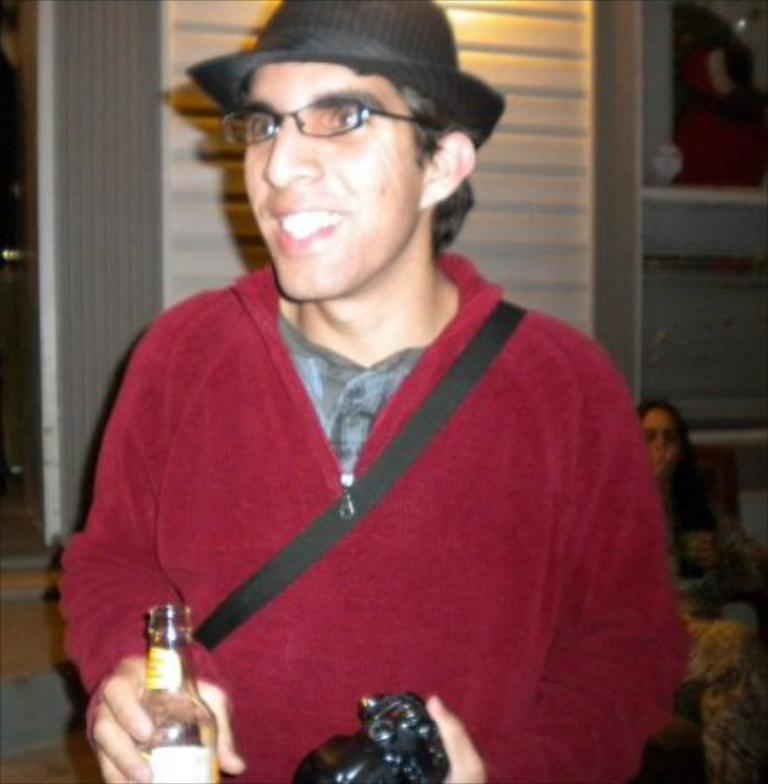What is the man in the image doing? The man is standing and holding a wine bottle and a camera. What is the woman in the image doing? The woman is sitting on a chair. What objects is the man holding in the image? The man is holding a wine bottle and a camera. What type of apparel is the balloon wearing in the image? There is no balloon present in the image, so it is not possible to determine what type of apparel it might be wearing. 